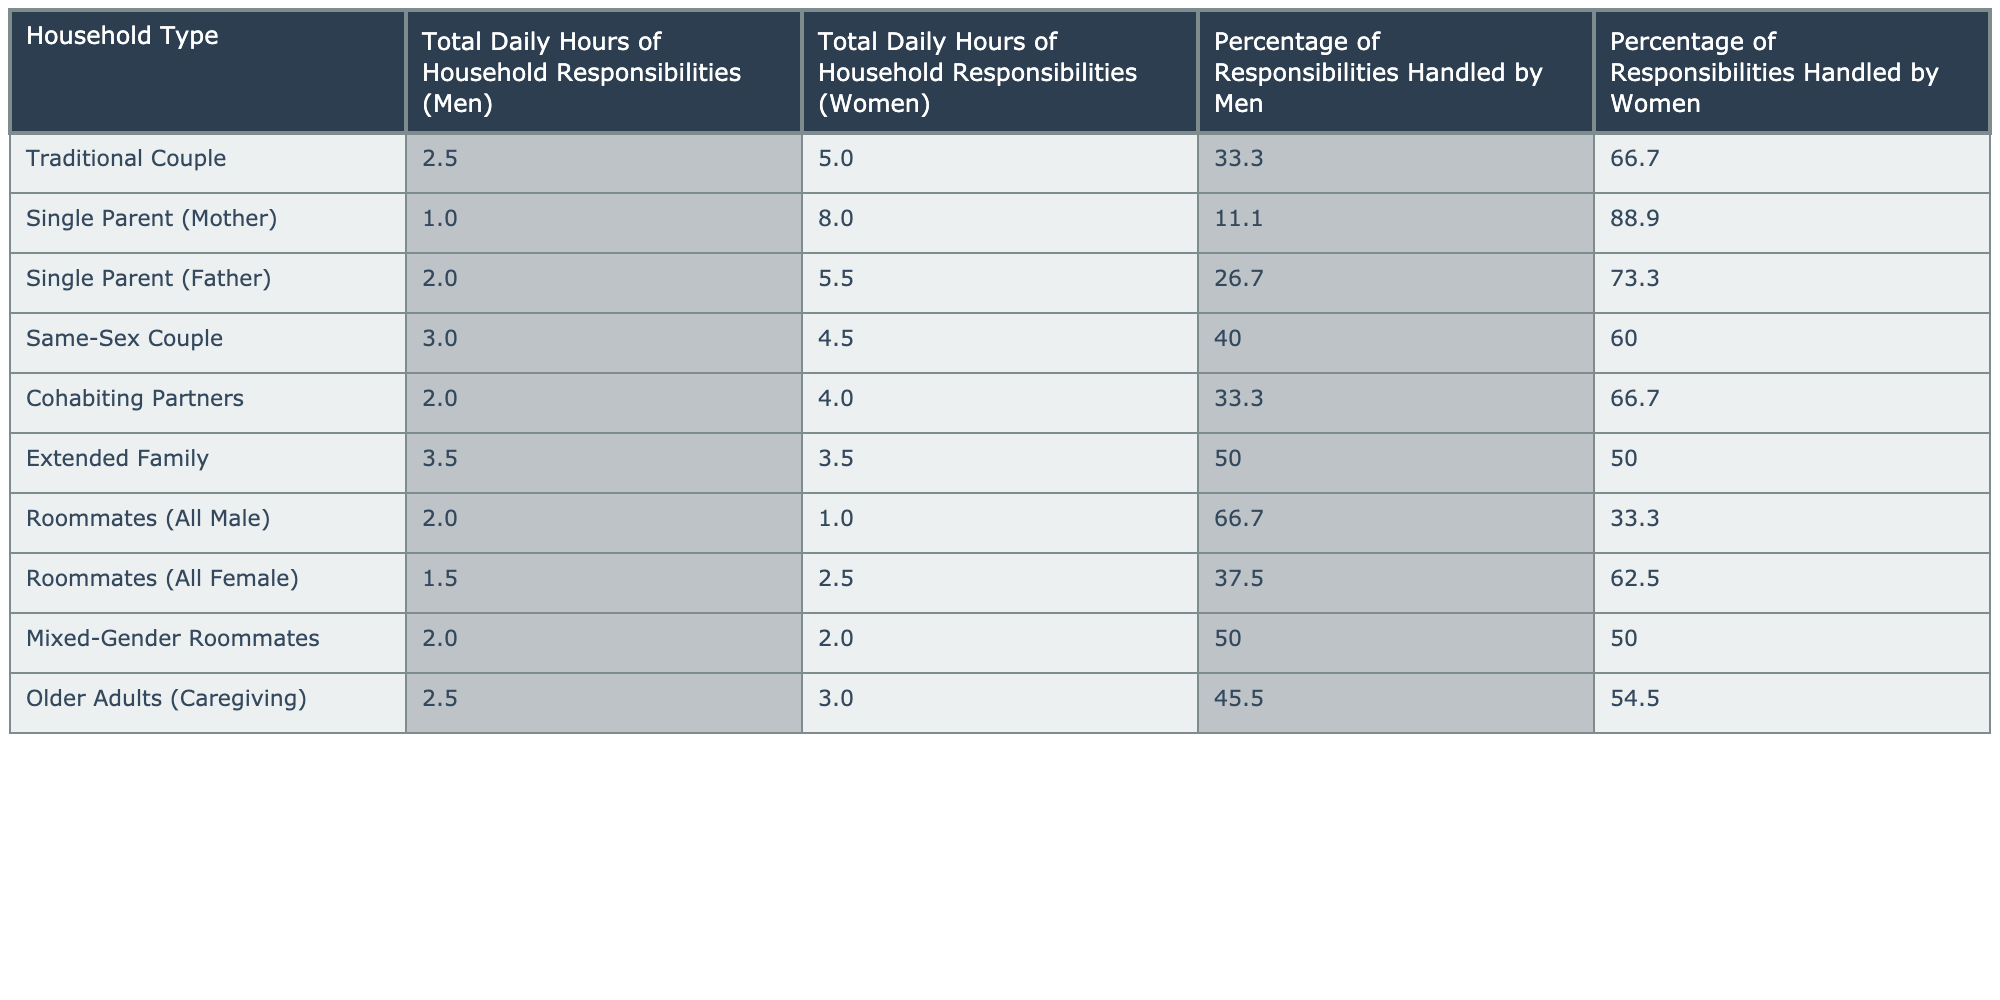What's the total daily hours of household responsibilities for women in a Traditional Couple household? According to the table, women in a Traditional Couple household handle a total of 5.0 hours of household responsibilities per day.
Answer: 5.0 hours In which household type do men have the highest percentage of responsibilities? Looking at the table, men have the highest percentage of responsibilities in the Roommates (All Male) category, where they handle 66.7% of the responsibilities.
Answer: Roommates (All Male) What is the total daily hours of household responsibilities for men and women in an Extended Family? For an Extended Family, men handle 3.5 hours, and women also handle 3.5 hours. Therefore, the total is 3.5 + 3.5 = 7.0 hours.
Answer: 7.0 hours Which household type has the lowest total daily hours of household responsibilities for men? The Single Parent (Mother) household type has the lowest total daily hours of household responsibilities for men, with just 1.0 hour.
Answer: Single Parent (Mother) What is the combined percentage of responsibilities handled by women in Single Parent (Father) and Same-Sex Couple households? In the Single Parent (Father) household, the percentage handled by women is 73.3%, and in the Same-Sex Couple, it is 60.0%. Adding these gives 73.3 + 60.0 = 133.3%.
Answer: 133.3% Is it true that women in Cohabiting Partners handle more responsibilities than women in Same-Sex Couples? Yes, women in Cohabiting Partners handle 66.7% of responsibilities compared to 60.0% for Same-Sex Couples, which confirms the statement.
Answer: Yes What is the difference in total daily hours of household responsibilities between men in Traditional Couples and Extended Families? Men in Traditional Couples handle 2.5 hours, while in Extended Families, they handle 3.5 hours. The difference is 3.5 - 2.5 = 1.0 hour.
Answer: 1.0 hour What percentage of responsibilities do women handle in Mixed-Gender Roommates, and how does that compare to Roommates (All Female)? Women handle 50.0% of responsibilities in Mixed-Gender Roommates and 62.5% in Roommates (All Female). The comparison shows that women handle 12.5% more in Roommates (All Female) than in Mixed-Gender Roommates.
Answer: 12.5% more Calculate the average daily hours handled by men across all household types. Summing the total daily hours handled by men in all categories gives (2.5 + 1.0 + 2.0 + 3.0 + 2.0 + 3.5 + 2.0 + 2.0 + 2.5) = 18.5 hours. Dividing by the 9 household types gives an average of 18.5 / 9 = approximately 2.06 hours.
Answer: 2.06 hours Which household type has the most balanced percentage of responsibilities handled by both genders? The Extended Family shows a perfectly balanced situation, as both men and women handle 50.0% of responsibilities, making it the most equitable.
Answer: Extended Family What is the ratio of total daily hours of household responsibilities between men and women in the Single Parent (Mother) household? In the Single Parent (Mother) household, men handle 1.0 hour and women handle 8.0 hours. The ratio is 1:8, indicating that women handle 8 times more responsibilities than men.
Answer: 1:8 